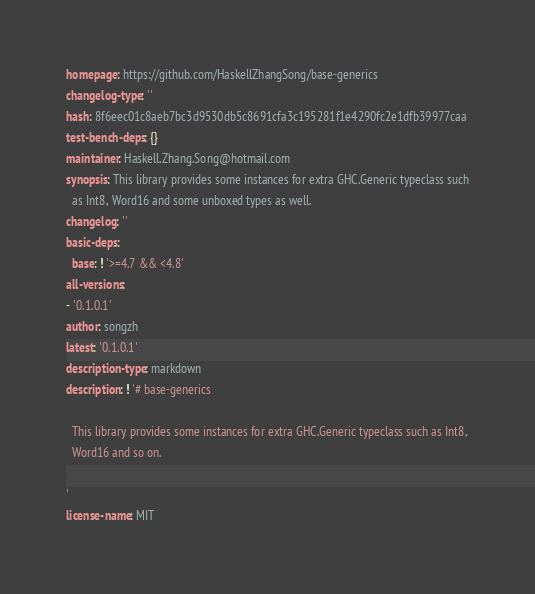<code> <loc_0><loc_0><loc_500><loc_500><_YAML_>homepage: https://github.com/HaskellZhangSong/base-generics
changelog-type: ''
hash: 8f6eec01c8aeb7bc3d9530db5c8691cfa3c195281f1e4290fc2e1dfb39977caa
test-bench-deps: {}
maintainer: Haskell.Zhang.Song@hotmail.com
synopsis: This library provides some instances for extra GHC.Generic typeclass such
  as Int8, Word16 and some unboxed types as well.
changelog: ''
basic-deps:
  base: ! '>=4.7 && <4.8'
all-versions:
- '0.1.0.1'
author: songzh
latest: '0.1.0.1'
description-type: markdown
description: ! '# base-generics

  This library provides some instances for extra GHC.Generic typeclass such as Int8,
  Word16 and so on.

'
license-name: MIT
</code> 